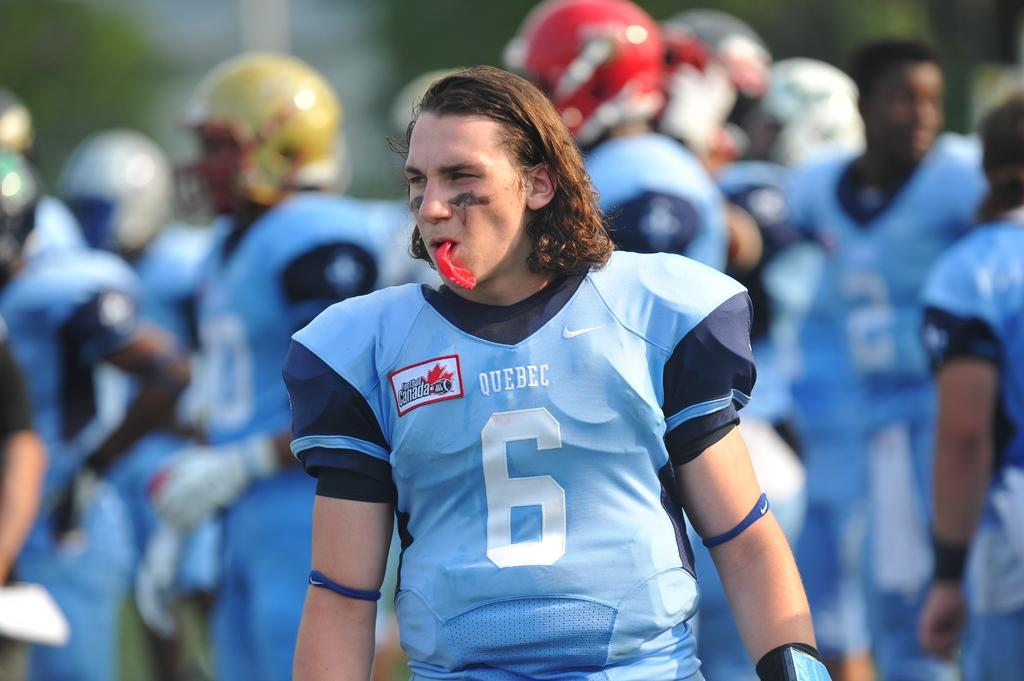What is the main subject of the image? There is a person in the image. Can you describe the person's attire? The person is wearing a blue dress. What is the person doing in the image? The person has something in his mouth. What can be seen in the background of the image? There is a group of people in the background of the image. Can you describe the group of people? The group of people is wearing blue. What type of war is being depicted in the image? There is no war depicted in the image; it features a person wearing a blue dress and a group of people wearing blue in the background. How does the acoustics of the room affect the person's ability to speak in the image? The image does not provide any information about the acoustics of the room, so it cannot be determined how it affects the person's ability to speak. 